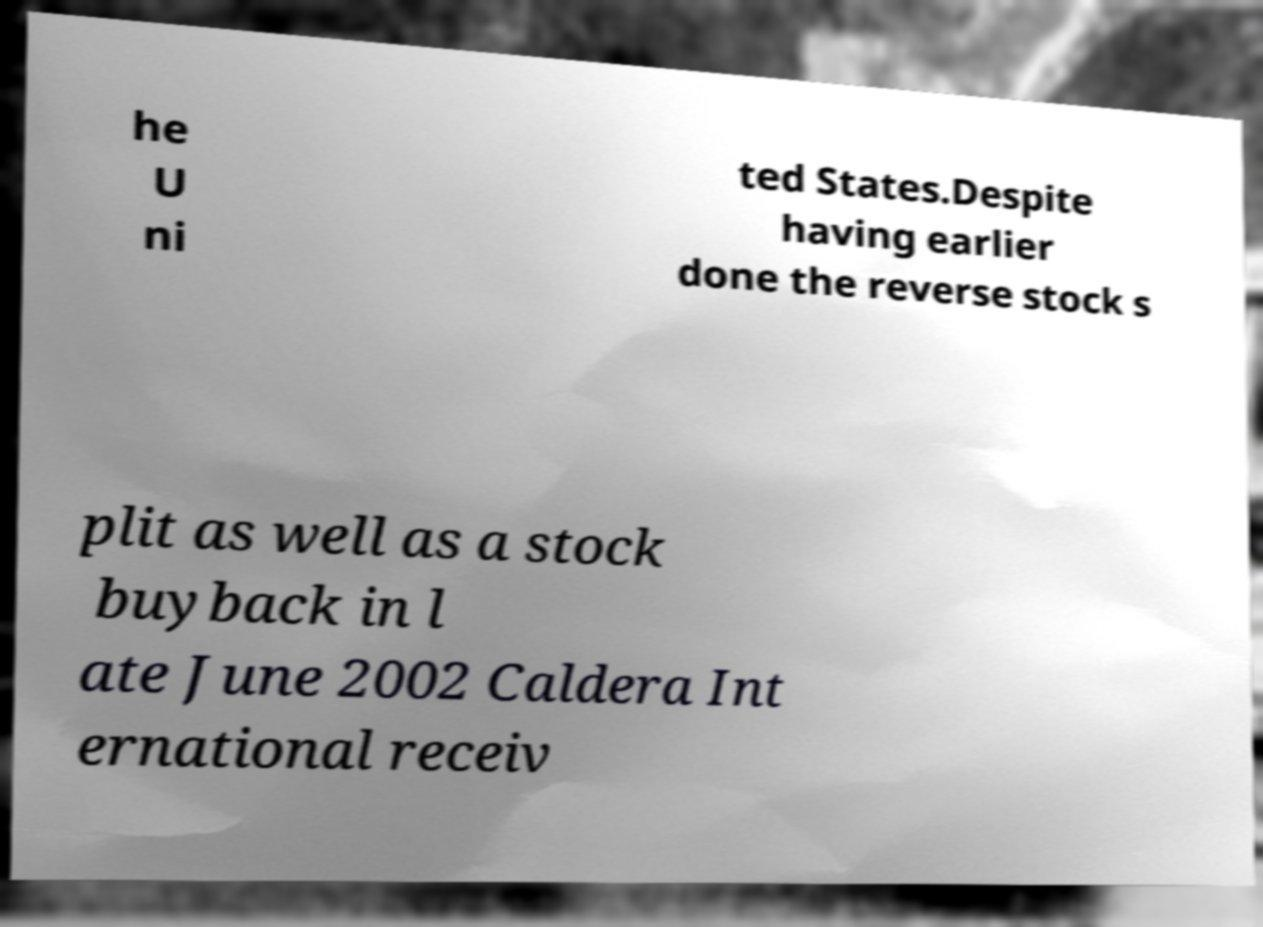Please identify and transcribe the text found in this image. he U ni ted States.Despite having earlier done the reverse stock s plit as well as a stock buyback in l ate June 2002 Caldera Int ernational receiv 